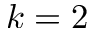<formula> <loc_0><loc_0><loc_500><loc_500>k = 2</formula> 